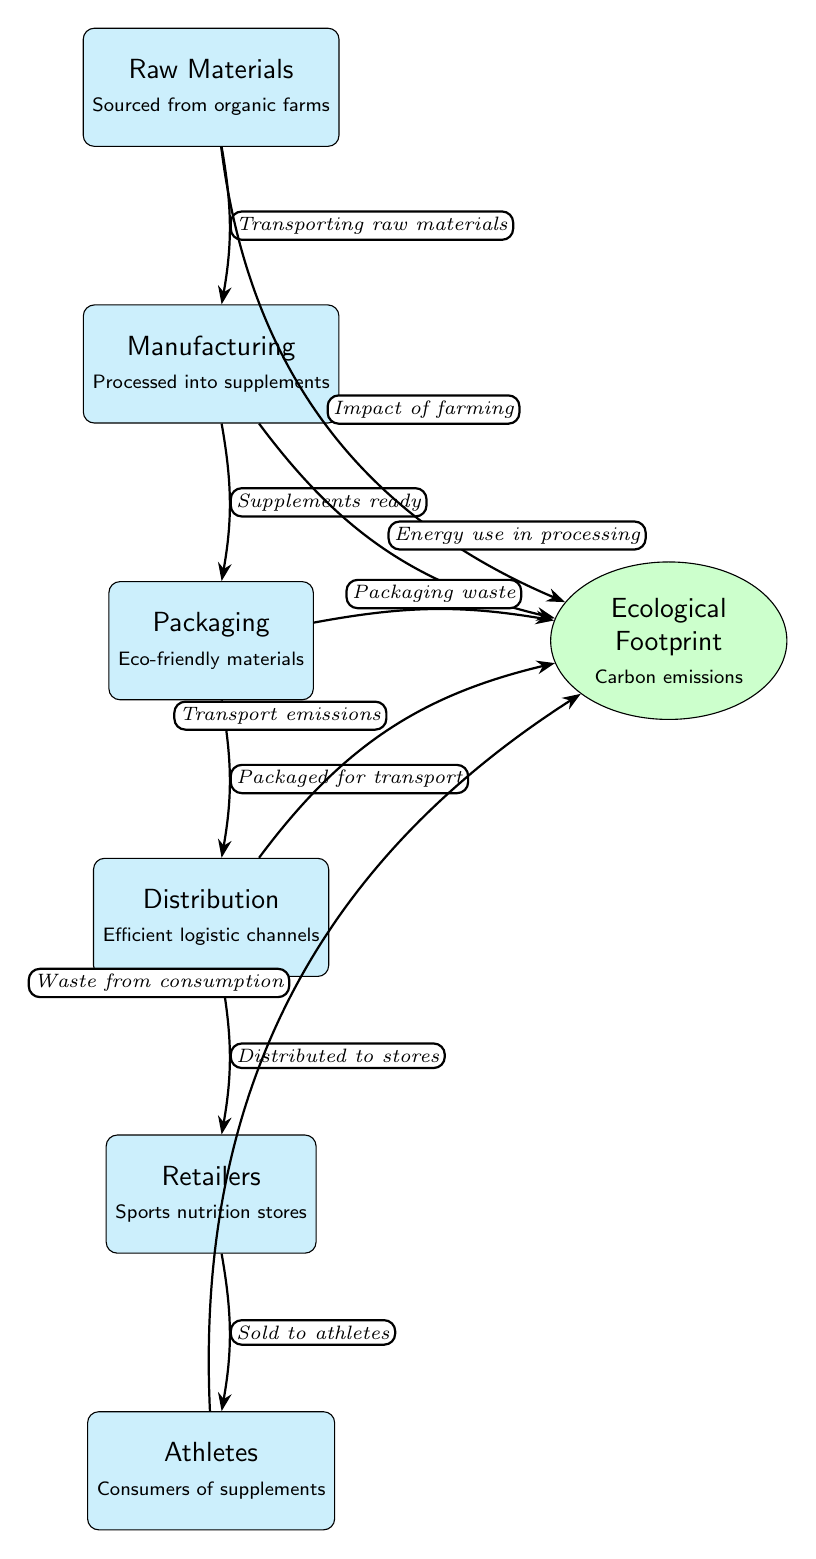What are the raw materials sourced from? The diagram specifies that raw materials are sourced from "organic farms," which is indicated in the node labeled "Raw Materials."
Answer: organic farms How many main nodes are in the diagram? The diagram has six main nodes representing different stages in the supply chain. Each main node is visually represented and contains distinct stages: Raw Materials, Manufacturing, Packaging, Distribution, Retailers, and Athletes.
Answer: 6 What type of materials are used in packaging? The diagram states that packaging uses "Eco-friendly materials," which is detailed in the "Packaging" node.
Answer: Eco-friendly materials What impact does farming have on the ecological footprint? According to the diagram, the "Impact of farming" connects from the "Raw Materials" node to the "Ecological Footprint" node, indicating that farming contributes to the ecological footprint.
Answer: Impact of farming What is the first step in the supply chain? The diagram indicates that the first step in the supply chain is "Raw Materials," showing that it is the starting point for the process.
Answer: Raw Materials What is the relationship between packaging and ecological footprint? The diagram illustrates that there is a direct connection from "Packaging" to "Ecological Footprint" detailing "Packaging waste," indicating an environmental impact from packaging materials.
Answer: Packaging waste How does distribution impact the ecological footprint? The diagram shows that "Distribution" connects to the "Ecological Footprint" through "Transport emissions," therefore indicating that emissions from transportation during distribution affect the ecological footprint.
Answer: Transport emissions What phase is directly before the athletes in the supply chain? "Retailers" is the phase that comes directly before "Athletes" in the supply chain, as shown in the flow of the diagram from "Retailers" to "Athletes."
Answer: Retailers 